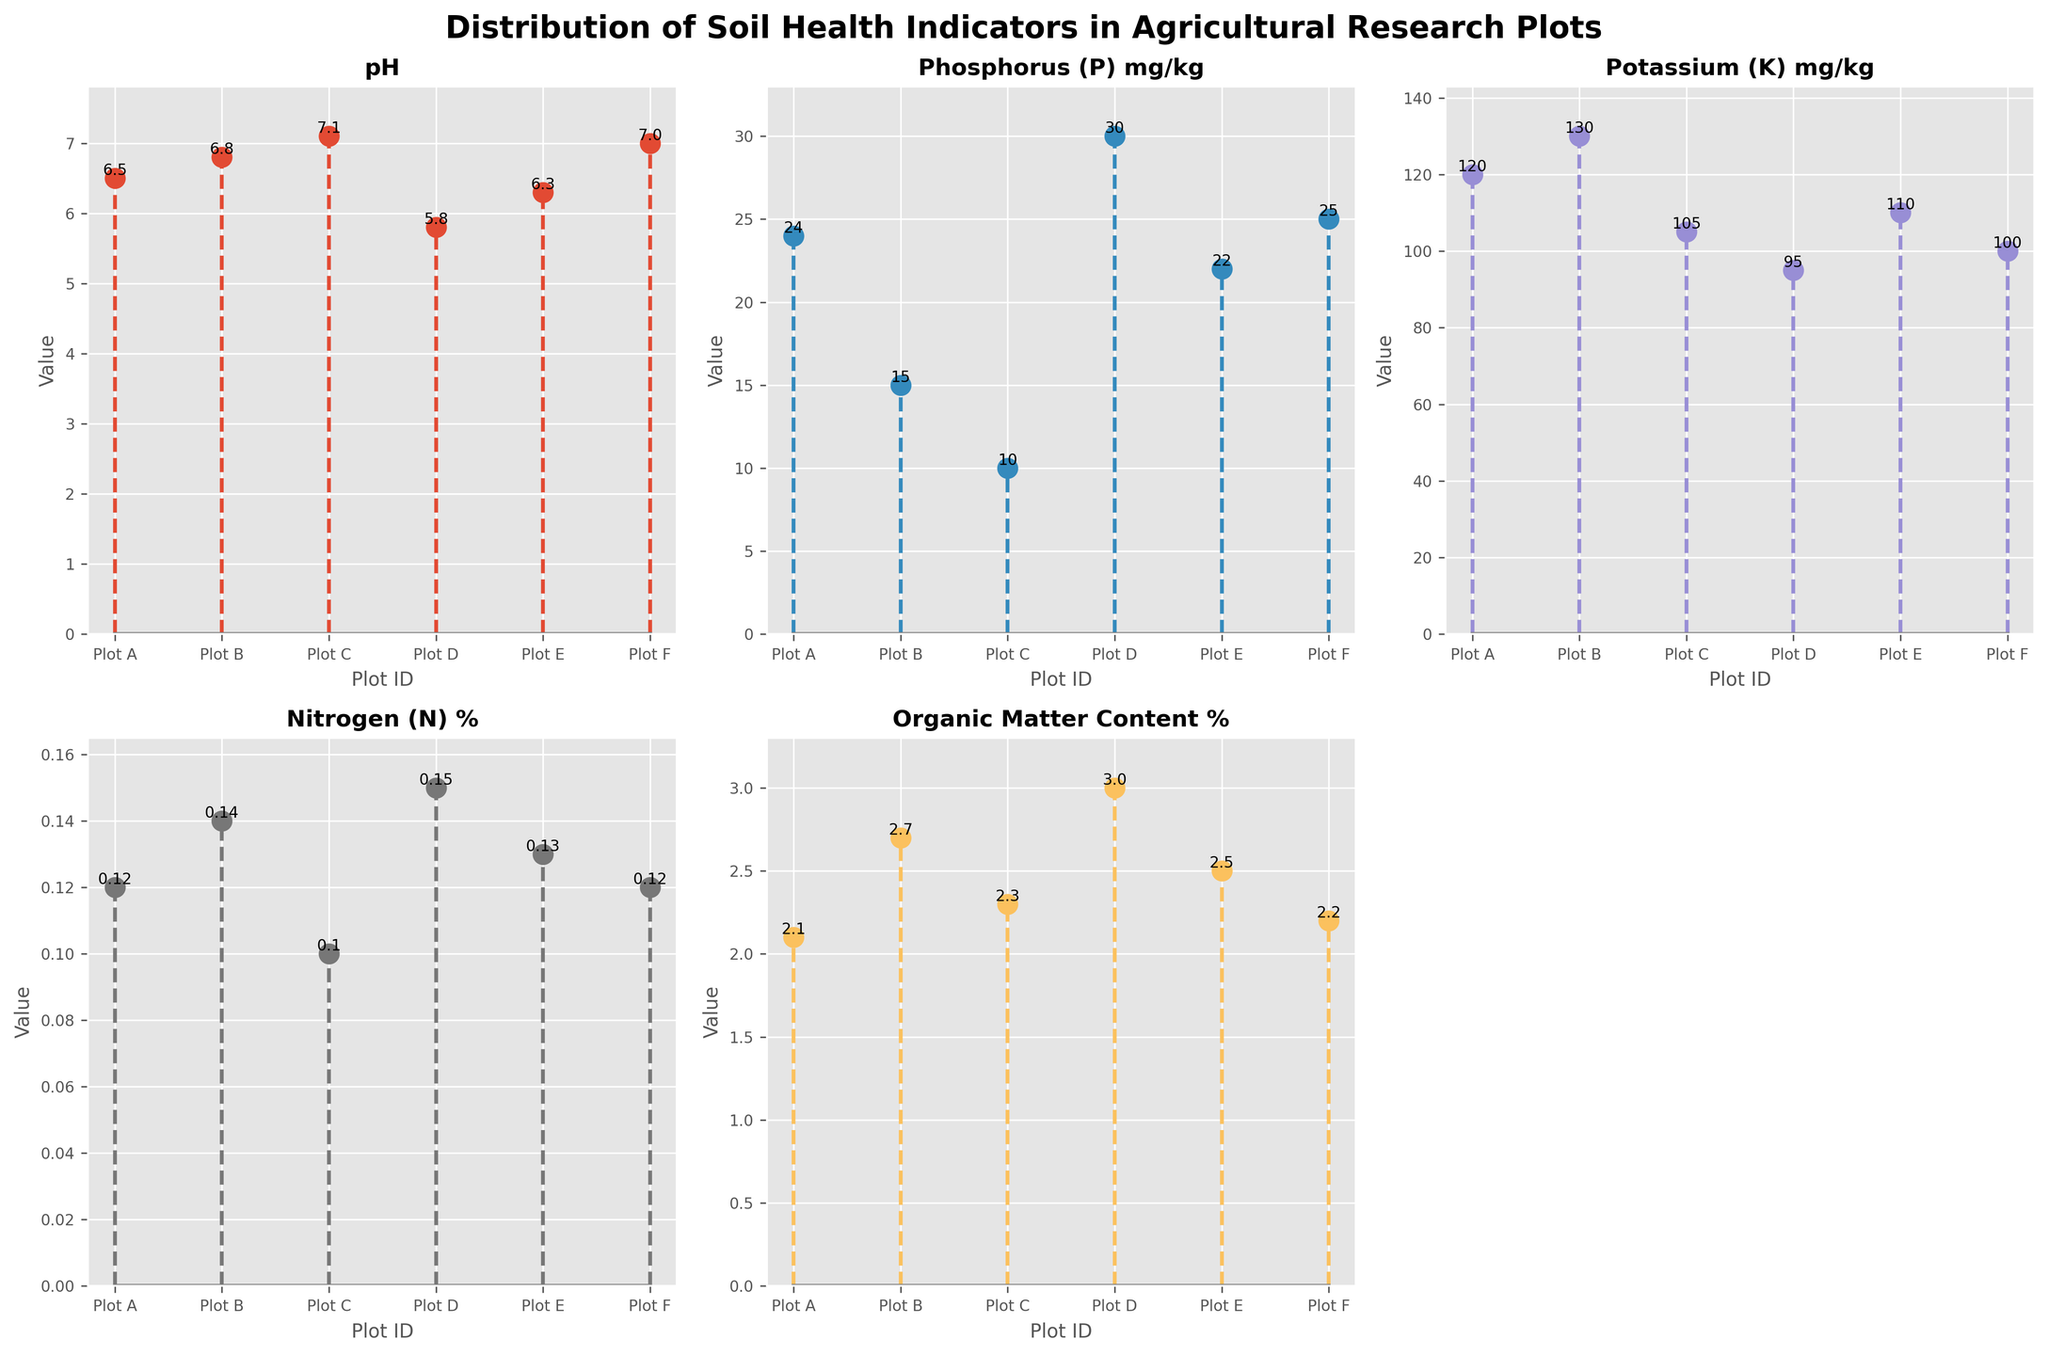Which plot ID has the highest pH value? The plot with the highest pH value will have the tallest stem in the subplot for pH. By inspecting the pH subplot, Plot C has the highest stem.
Answer: Plot C Which soil health indicator has the highest overall maximum value? The subplot with the tallest stem across all indicators determines the highest maximum value. The tallest stem is observed in the Phosphorus (P) mg/kg subplot, where Plot D reaches 30 mg/kg.
Answer: Phosphorus (P) What is the overall trend in Organic Matter Content % across the plots? Reviewing the subplot for Organic Matter Content %, we see values gradually vary with a slight rise and fall, but no consistent upward or downward trend.
Answer: No clear trend In which plot does Nitrogen (N) % reach its highest value? To find the highest Nitrogen (N) %, inspect the subplot for the tallest stem. Plot D, with a value of 0.15%, has the highest stem.
Answer: Plot D How does Potassium (K) mg/kg in Plot F compare to Plot D? In the Potassium (K) mg/kg subplot, the stem for Plot F is at 100 mg/kg, whereas for Plot D, the stem is at 95 mg/kg. Thus, Plot F has a higher Potassium level.
Answer: Plot F is higher Which indicator displays the lowest value in Plot B, and what is that value? Check the stems for Plot B in all subplots. The lowest stem corresponds to Phosphorus (P) mg/kg, with a value of 15 mg/kg.
Answer: Phosphorus (P) mg/kg, 15 Calculate the average pH value across all plots. Sum the pH values (6.5 + 6.8 + 7.1 + 5.8 + 6.3 + 7.0) = 39.5 and divide by the number of plots (6). The average pH is 39.5 / 6 = 6.58.
Answer: 6.58 Which plot has the most balanced distribution of soil health indicators in terms of relative values? A balanced plot would show relatively similar stem heights across indicators. Plot E displays an even distribution without significant disparities.
Answer: Plot E 